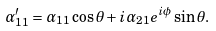<formula> <loc_0><loc_0><loc_500><loc_500>\alpha ^ { \prime } _ { 1 1 } = \alpha _ { 1 1 } \cos \theta + i \alpha _ { 2 1 } e ^ { i \phi } \sin \theta .</formula> 